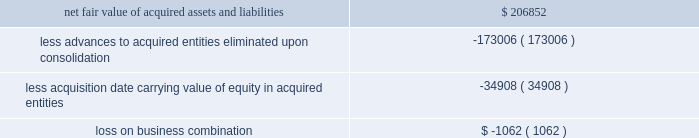58| | duke realty corporation annual report 2009 we recognized a loss of $ 1.1 million upon acquisition , which represents the difference between the fair value of the recognized assets and the carrying value of our pre-existing equity interest .
The acquisition date fair value of the net recognized assets as compared to the acquisition date carrying value of our outstanding advances and accrued interest , as well as the acquisition date carrying value of our pre-existing equity interests , is shown as follows ( in thousands ) : .
Since april 1 , 2009 , the results of operations for both acquired entities have been included in continuing operations in our consolidated financial statements .
Due to our significant pre-existing ownership and financing positions in the two acquired entities , the inclusion of their results of operations did not have a material effect on our operating income .
Acquisitions we acquired income producing real estate related assets of $ 32.1 million , $ 60.5 million and $ 219.9 million in 2009 , 2008 and 2007 , respectively .
In december 2007 , in order to further establish our property positions around strategic port locations , we purchased a portfolio of five industrial buildings in seattle , virginia and houston , as well as approximately 161 acres of undeveloped land and a 12-acre container storage facility in houston .
The total price was $ 89.7 million and was financed in part through assumption of secured debt that had a fair value of $ 34.3 million .
Of the total purchase price , $ 64.1 million was allocated to in-service real estate assets , $ 20.0 million was allocated to undeveloped land and the container storage facility , $ 5.4 million was allocated to lease related intangible assets , and the remaining amount was allocated to acquired working capital related assets and liabilities .
The results of operations for the acquired properties since the date of acquisition have been included in continuing rental operations in our consolidated financial statements .
All other acquisitions were not individually material .
Dispositions we disposed of income producing real estate related assets with gross proceeds of $ 267.0 million , $ 426.2 million and $ 590.4 million in 2009 , 2008 and 2007 , respectively .
We sold five properties in 2009 and seven properties in 2008 to an unconsolidated joint venture .
The gross proceeds totaled $ 84.3 million and $ 226.2 million for the years ended december 31 , 2009 and 2008 , respectively .
In march 2007 , as part of our capital recycling program , we sold a portfolio of eight suburban office properties totaling 894000 square feet in the cleveland market .
The sales price totaled $ 140.4 million , of which we received net proceeds of $ 139.3 million .
We also sold a portfolio of twelve flex and light industrial properties in july 2007 , totaling 865000 square feet in the st .
Louis market , for a sales price of $ 65.0 million , of which we received net proceeds of $ 64.2 million .
All other dispositions were not individually material .
( 4 ) related party transactions we provide property management , leasing , construction and other tenant related services to unconsolidated companies in which we have equity interests .
For the years ended december 31 , 2009 , 2008 and 2007 , respectively , we earned management fees of $ 8.4 million , $ 7.8 million and $ 7.1 million , leasing fees of $ 4.2 million , $ 2.8 million and $ 4.2 million and construction and development fees of $ 10.2 million , $ 12.7 million and $ 13.1 million from these companies .
We recorded these fees based on contractual terms that approximate market rates for these types of .
Of the december 2007 property purchase what was the percent of assets allocated to allocated to in-service real estate assets? 
Rationale: of the december 2007 property purchase 71.5 of assets was allocated to allocated to in-service real estate assets
Computations: (64.1 / 89.7)
Answer: 0.7146. 